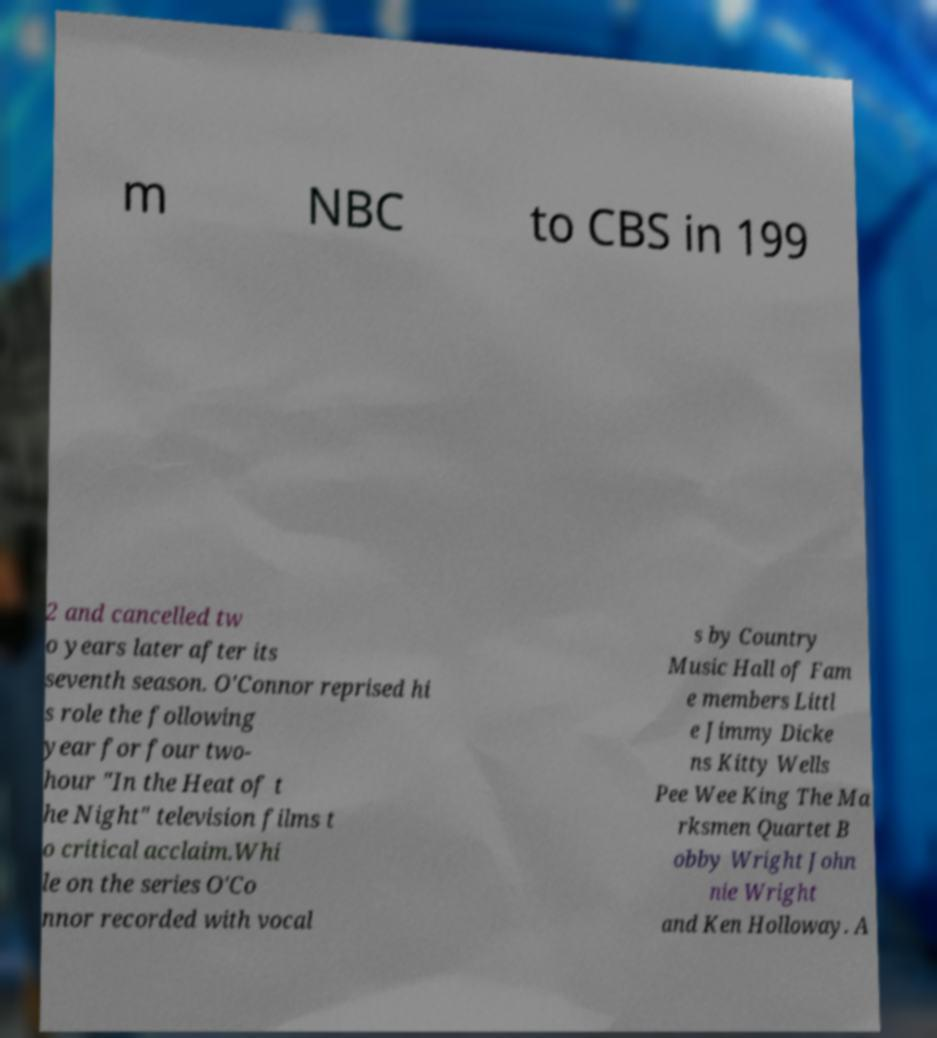I need the written content from this picture converted into text. Can you do that? m NBC to CBS in 199 2 and cancelled tw o years later after its seventh season. O'Connor reprised hi s role the following year for four two- hour "In the Heat of t he Night" television films t o critical acclaim.Whi le on the series O'Co nnor recorded with vocal s by Country Music Hall of Fam e members Littl e Jimmy Dicke ns Kitty Wells Pee Wee King The Ma rksmen Quartet B obby Wright John nie Wright and Ken Holloway. A 